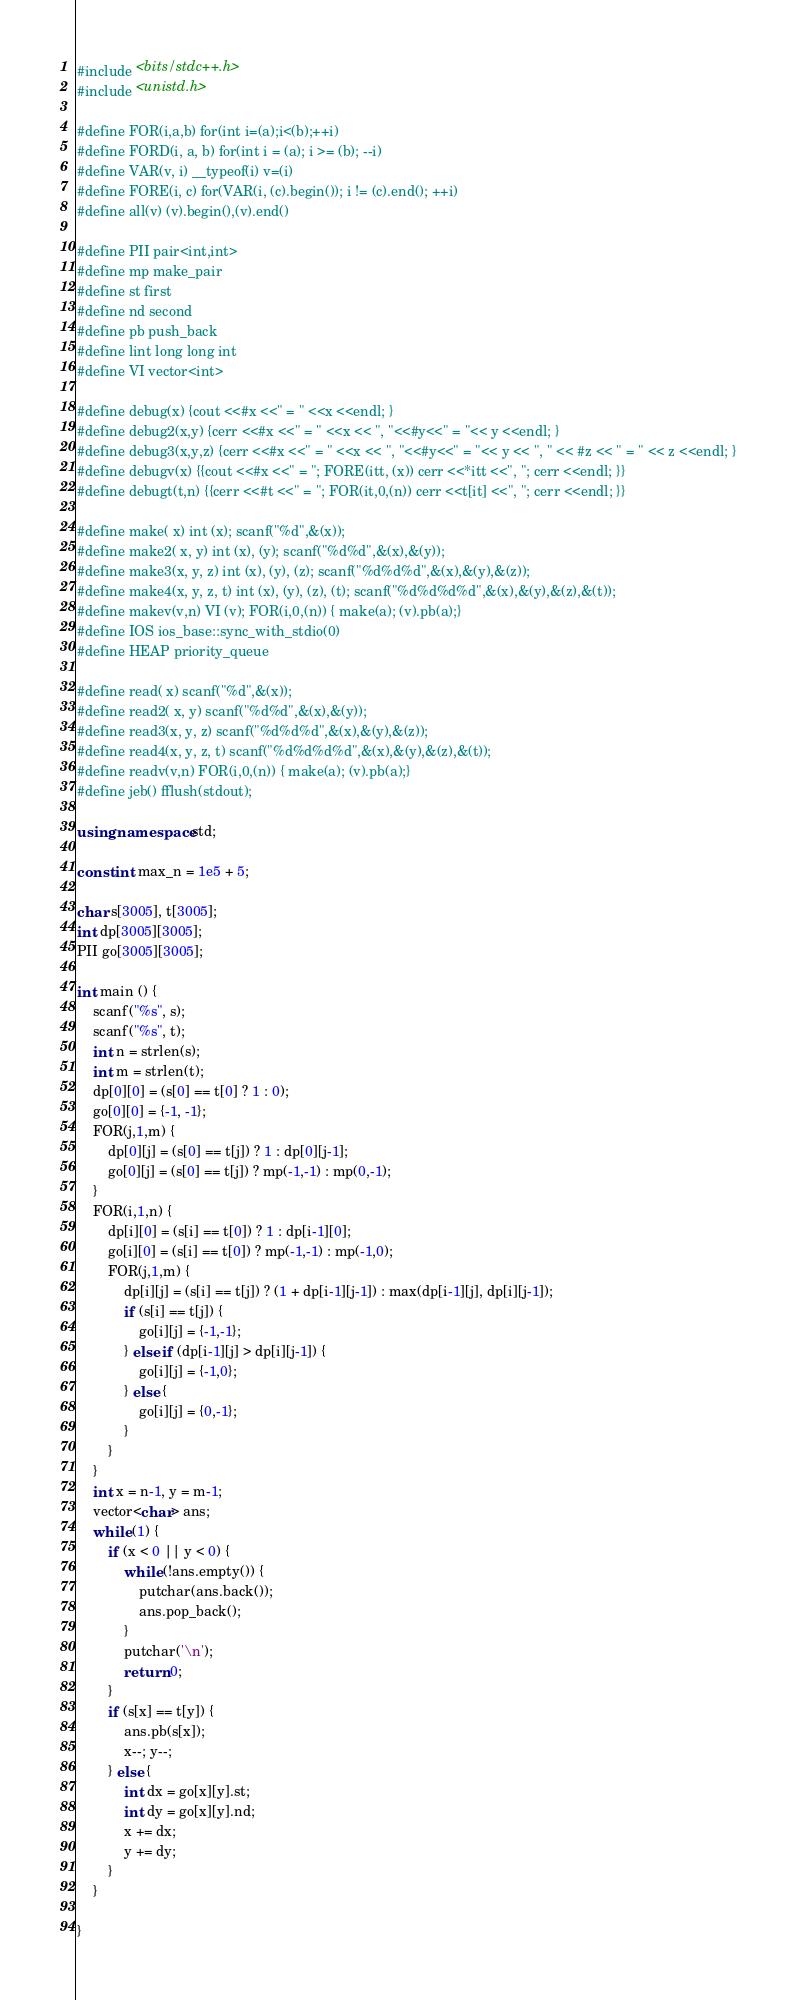Convert code to text. <code><loc_0><loc_0><loc_500><loc_500><_C++_>#include <bits/stdc++.h>
#include <unistd.h>

#define FOR(i,a,b) for(int i=(a);i<(b);++i)
#define FORD(i, a, b) for(int i = (a); i >= (b); --i)
#define VAR(v, i) __typeof(i) v=(i)
#define FORE(i, c) for(VAR(i, (c).begin()); i != (c).end(); ++i)
#define all(v) (v).begin(),(v).end()

#define PII pair<int,int>
#define mp make_pair
#define st first
#define nd second
#define pb push_back
#define lint long long int
#define VI vector<int>

#define debug(x) {cout <<#x <<" = " <<x <<endl; }
#define debug2(x,y) {cerr <<#x <<" = " <<x << ", "<<#y<<" = "<< y <<endl; } 
#define debug3(x,y,z) {cerr <<#x <<" = " <<x << ", "<<#y<<" = "<< y << ", " << #z << " = " << z <<endl; } 
#define debugv(x) {{cout <<#x <<" = "; FORE(itt, (x)) cerr <<*itt <<", "; cerr <<endl; }}
#define debugt(t,n) {{cerr <<#t <<" = "; FOR(it,0,(n)) cerr <<t[it] <<", "; cerr <<endl; }}

#define make( x) int (x); scanf("%d",&(x));
#define make2( x, y) int (x), (y); scanf("%d%d",&(x),&(y));
#define make3(x, y, z) int (x), (y), (z); scanf("%d%d%d",&(x),&(y),&(z));
#define make4(x, y, z, t) int (x), (y), (z), (t); scanf("%d%d%d%d",&(x),&(y),&(z),&(t));
#define makev(v,n) VI (v); FOR(i,0,(n)) { make(a); (v).pb(a);} 
#define IOS ios_base::sync_with_stdio(0)
#define HEAP priority_queue

#define read( x) scanf("%d",&(x));
#define read2( x, y) scanf("%d%d",&(x),&(y));
#define read3(x, y, z) scanf("%d%d%d",&(x),&(y),&(z));
#define read4(x, y, z, t) scanf("%d%d%d%d",&(x),&(y),&(z),&(t));
#define readv(v,n) FOR(i,0,(n)) { make(a); (v).pb(a);}
#define jeb() fflush(stdout);

using namespace std;

const int max_n = 1e5 + 5;

char s[3005], t[3005];
int dp[3005][3005];
PII go[3005][3005];

int main () {
	scanf("%s", s);
	scanf("%s", t);
	int n = strlen(s);
	int m = strlen(t);
	dp[0][0] = (s[0] == t[0] ? 1 : 0);
	go[0][0] = {-1, -1};
	FOR(j,1,m) {
		dp[0][j] = (s[0] == t[j]) ? 1 : dp[0][j-1];
		go[0][j] = (s[0] == t[j]) ? mp(-1,-1) : mp(0,-1);
	}
	FOR(i,1,n) {
		dp[i][0] = (s[i] == t[0]) ? 1 : dp[i-1][0];
		go[i][0] = (s[i] == t[0]) ? mp(-1,-1) : mp(-1,0);
		FOR(j,1,m) {
			dp[i][j] = (s[i] == t[j]) ? (1 + dp[i-1][j-1]) : max(dp[i-1][j], dp[i][j-1]);
			if (s[i] == t[j]) {
				go[i][j] = {-1,-1};
			} else if (dp[i-1][j] > dp[i][j-1]) {
				go[i][j] = {-1,0};
			} else {
				go[i][j] = {0,-1};
			}
		}
	}
	int x = n-1, y = m-1;
	vector<char> ans;
	while (1) {
		if (x < 0 || y < 0) {
			while (!ans.empty()) {
				putchar(ans.back());
				ans.pop_back();
			}
			putchar('\n');
			return 0;
		}
		if (s[x] == t[y]) {
			ans.pb(s[x]);
			x--; y--;
		} else {
			int dx = go[x][y].st;
			int dy = go[x][y].nd;
			x += dx;
			y += dy;
		}
	}

}	



</code> 